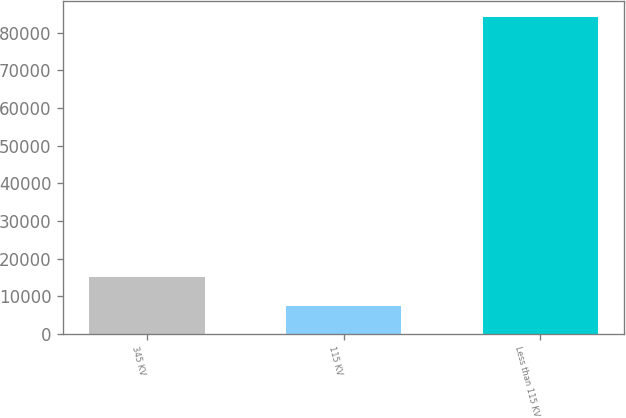Convert chart. <chart><loc_0><loc_0><loc_500><loc_500><bar_chart><fcel>345 KV<fcel>115 KV<fcel>Less than 115 KV<nl><fcel>15159.2<fcel>7502<fcel>84074<nl></chart> 